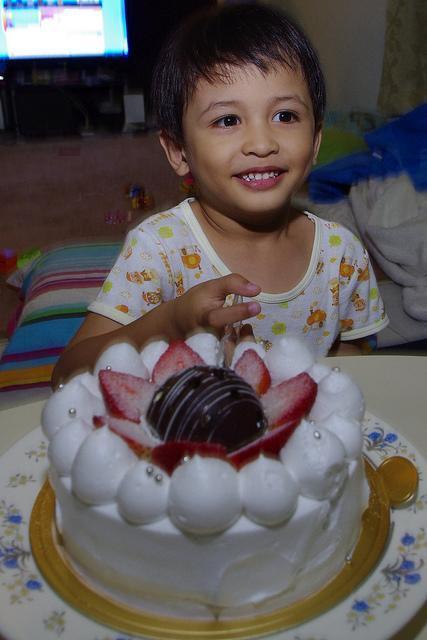Does the caption "The cake is touching the person." correctly depict the image?
Answer yes or no. No. Is this affirmation: "The cake is in front of the person." correct?
Answer yes or no. Yes. Is this affirmation: "The person is left of the cake." correct?
Answer yes or no. No. 